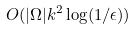<formula> <loc_0><loc_0><loc_500><loc_500>O ( | \Omega | k ^ { 2 } \log ( 1 / \epsilon ) )</formula> 